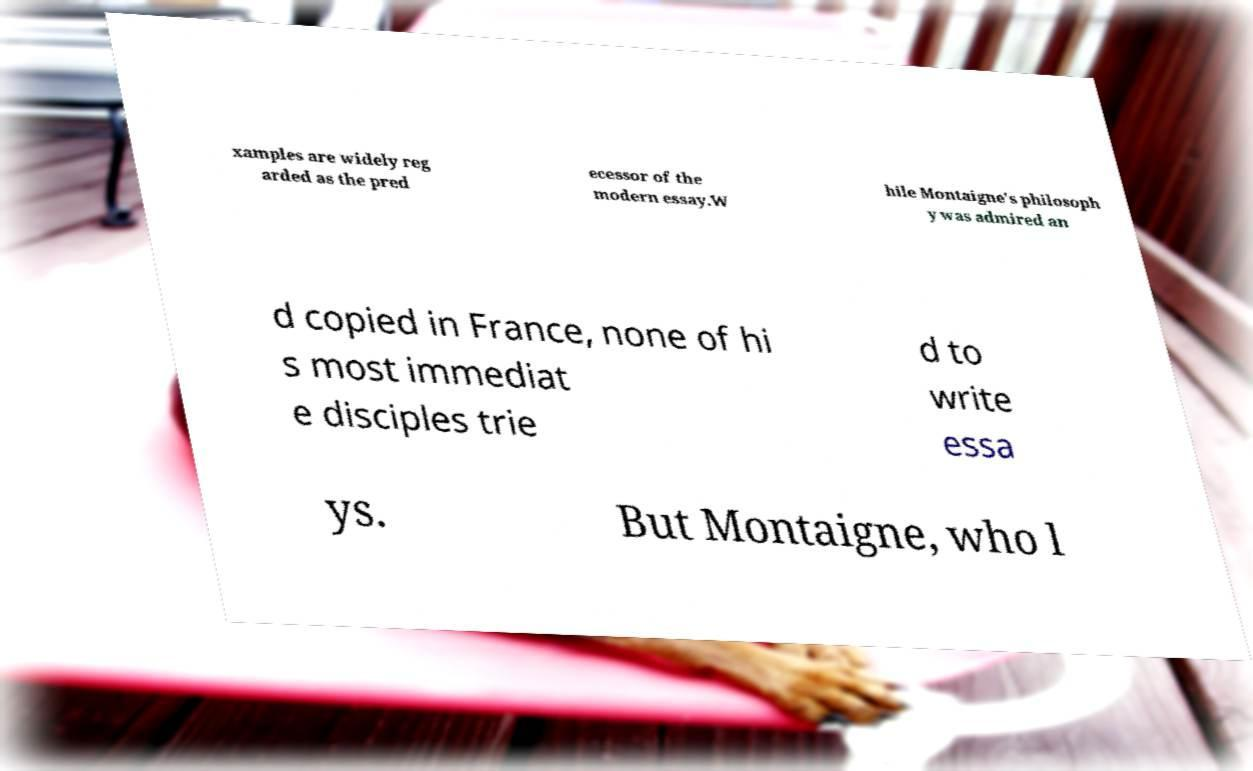Please read and relay the text visible in this image. What does it say? xamples are widely reg arded as the pred ecessor of the modern essay.W hile Montaigne's philosoph y was admired an d copied in France, none of hi s most immediat e disciples trie d to write essa ys. But Montaigne, who l 